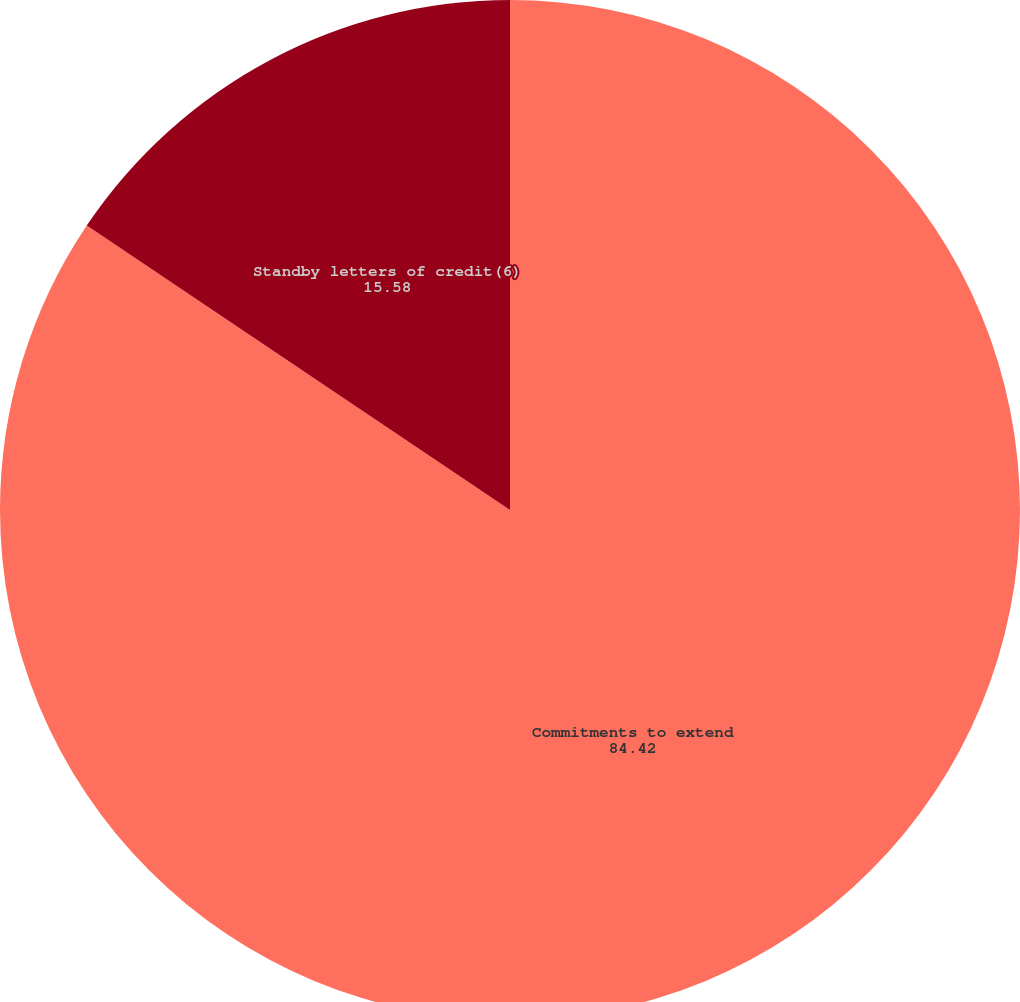Convert chart. <chart><loc_0><loc_0><loc_500><loc_500><pie_chart><fcel>Commitments to extend<fcel>Standby letters of credit(6)<nl><fcel>84.42%<fcel>15.58%<nl></chart> 